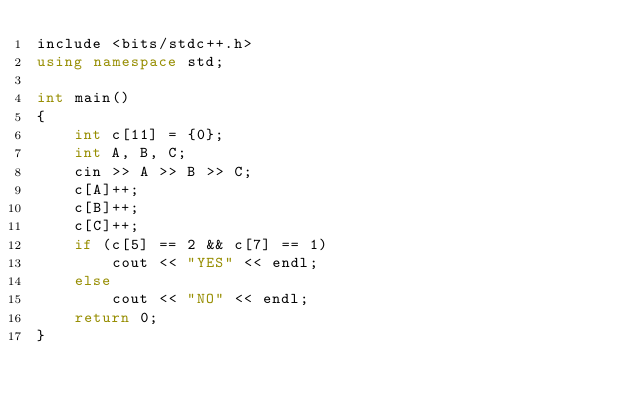Convert code to text. <code><loc_0><loc_0><loc_500><loc_500><_C++_>include <bits/stdc++.h>
using namespace std;

int main()
{
	int c[11] = {0};
  	int A, B, C;
  	cin >> A >> B >> C;
  	c[A]++;
  	c[B]++;
  	c[C]++;
  	if (c[5] == 2 && c[7] == 1)
      	cout << "YES" << endl;
  	else
      	cout << "NO" << endl;
	return 0;
}
</code> 